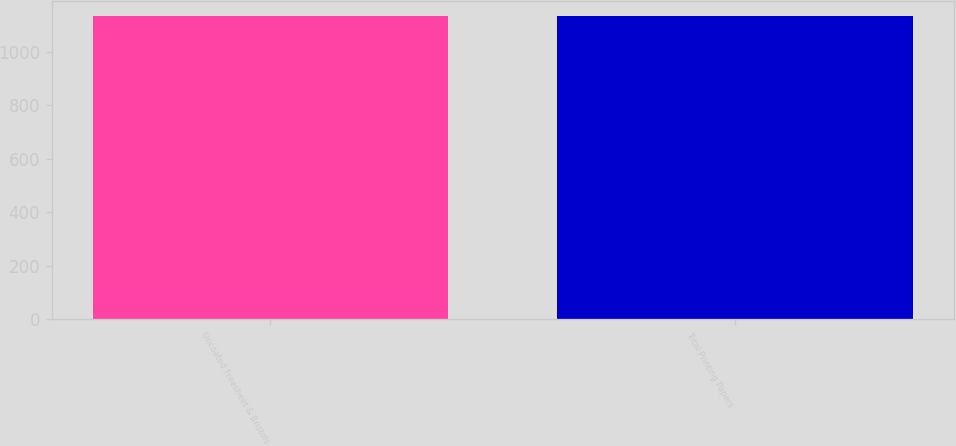Convert chart to OTSL. <chart><loc_0><loc_0><loc_500><loc_500><bar_chart><fcel>Uncoated Freesheet & Bristols<fcel>Total Printing Papers<nl><fcel>1135<fcel>1135.1<nl></chart> 